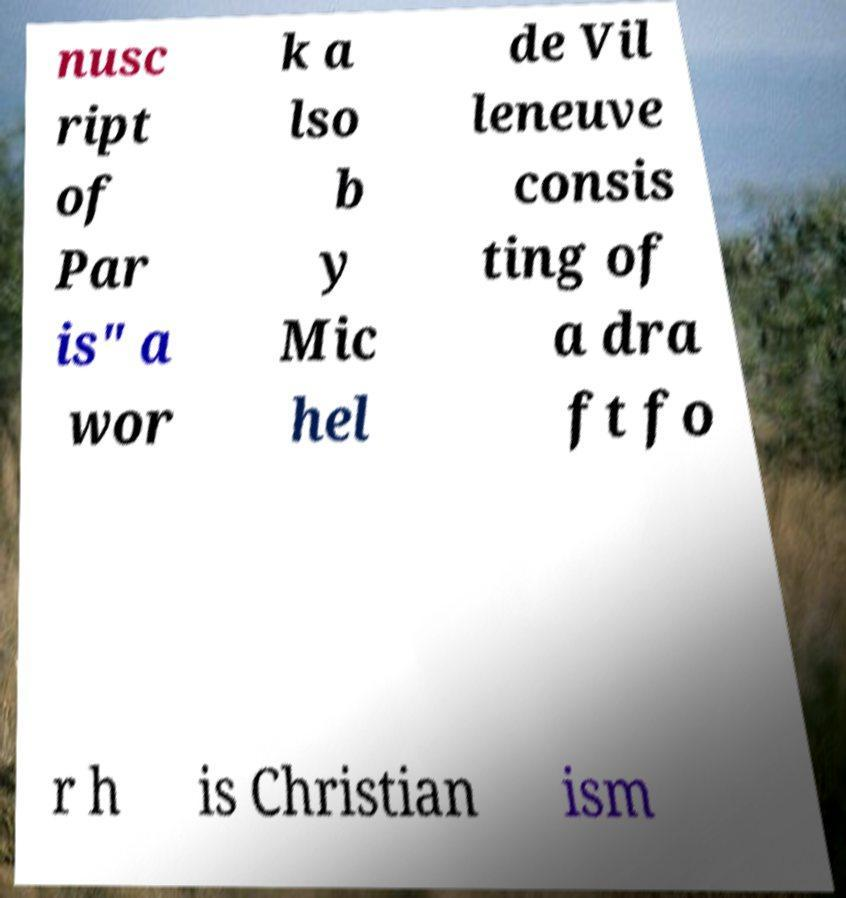Could you extract and type out the text from this image? nusc ript of Par is" a wor k a lso b y Mic hel de Vil leneuve consis ting of a dra ft fo r h is Christian ism 